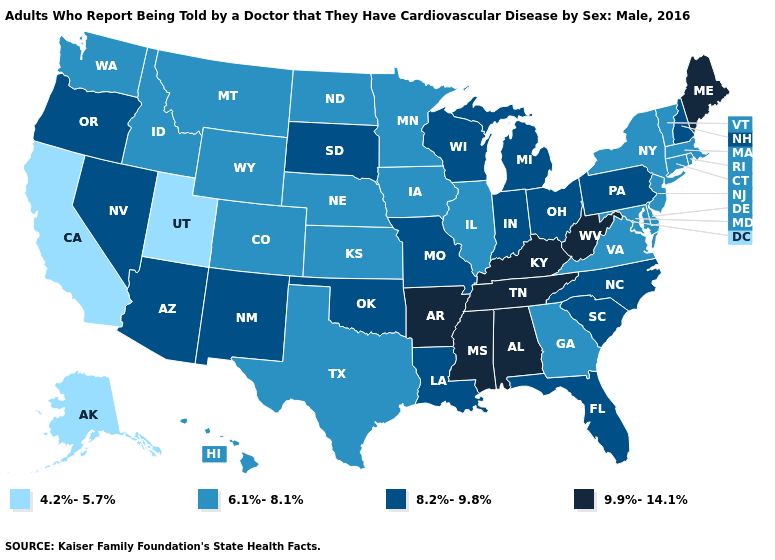Does Texas have a higher value than Kentucky?
Short answer required. No. Name the states that have a value in the range 9.9%-14.1%?
Short answer required. Alabama, Arkansas, Kentucky, Maine, Mississippi, Tennessee, West Virginia. Name the states that have a value in the range 6.1%-8.1%?
Keep it brief. Colorado, Connecticut, Delaware, Georgia, Hawaii, Idaho, Illinois, Iowa, Kansas, Maryland, Massachusetts, Minnesota, Montana, Nebraska, New Jersey, New York, North Dakota, Rhode Island, Texas, Vermont, Virginia, Washington, Wyoming. What is the value of Arkansas?
Give a very brief answer. 9.9%-14.1%. What is the value of New Mexico?
Concise answer only. 8.2%-9.8%. Name the states that have a value in the range 9.9%-14.1%?
Give a very brief answer. Alabama, Arkansas, Kentucky, Maine, Mississippi, Tennessee, West Virginia. What is the value of Oregon?
Short answer required. 8.2%-9.8%. What is the value of Missouri?
Quick response, please. 8.2%-9.8%. Does Utah have the lowest value in the USA?
Write a very short answer. Yes. Which states have the lowest value in the USA?
Quick response, please. Alaska, California, Utah. Does Hawaii have the lowest value in the USA?
Answer briefly. No. Is the legend a continuous bar?
Give a very brief answer. No. Name the states that have a value in the range 6.1%-8.1%?
Answer briefly. Colorado, Connecticut, Delaware, Georgia, Hawaii, Idaho, Illinois, Iowa, Kansas, Maryland, Massachusetts, Minnesota, Montana, Nebraska, New Jersey, New York, North Dakota, Rhode Island, Texas, Vermont, Virginia, Washington, Wyoming. What is the value of Maine?
Give a very brief answer. 9.9%-14.1%. 